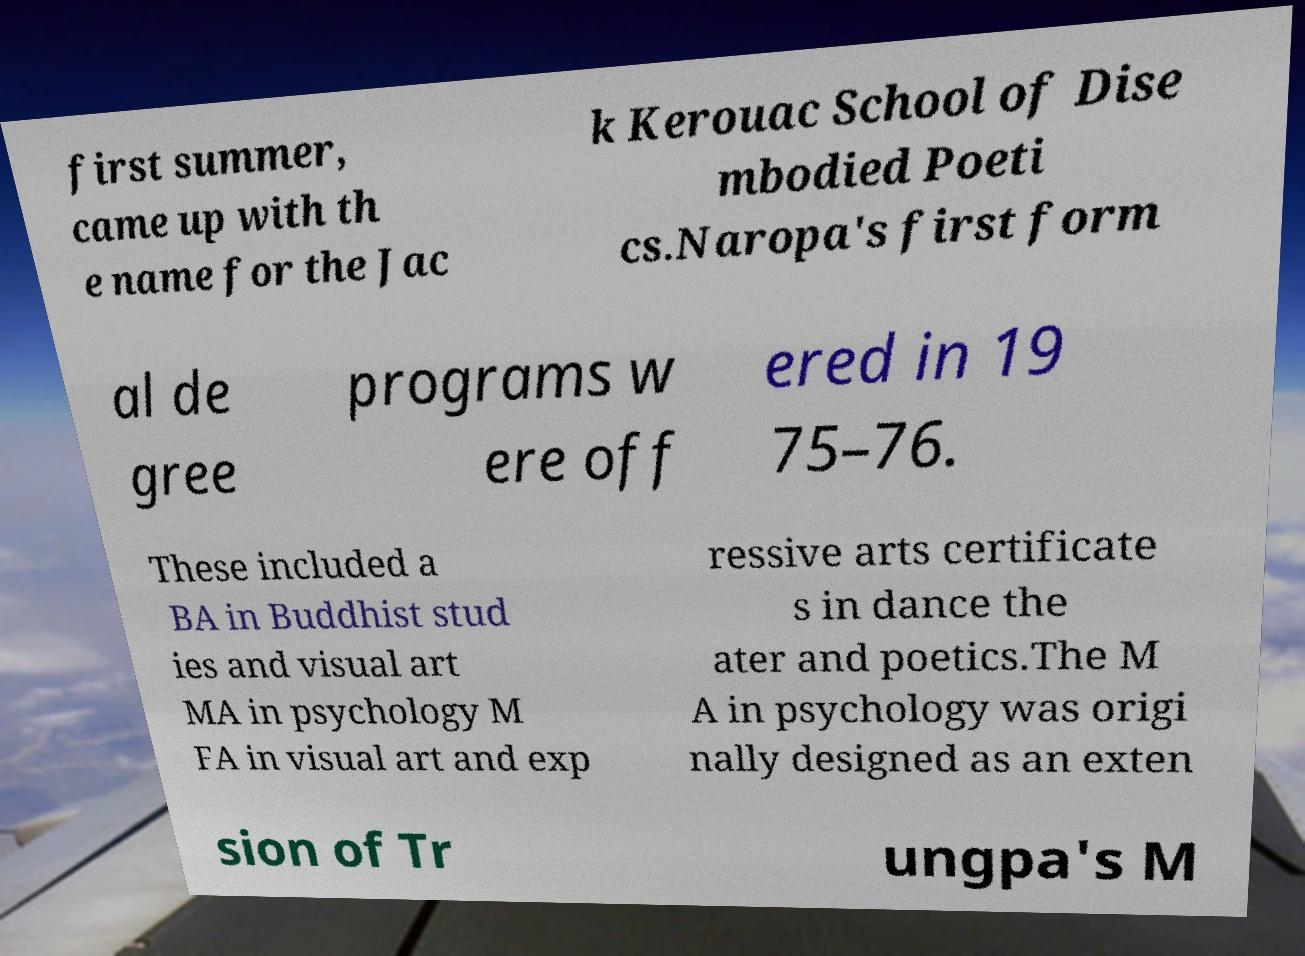There's text embedded in this image that I need extracted. Can you transcribe it verbatim? first summer, came up with th e name for the Jac k Kerouac School of Dise mbodied Poeti cs.Naropa's first form al de gree programs w ere off ered in 19 75–76. These included a BA in Buddhist stud ies and visual art MA in psychology M FA in visual art and exp ressive arts certificate s in dance the ater and poetics.The M A in psychology was origi nally designed as an exten sion of Tr ungpa's M 